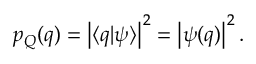Convert formula to latex. <formula><loc_0><loc_0><loc_500><loc_500>\begin{array} { r } { p _ { Q } ( q ) = \left | \langle q | \psi \rangle \right | ^ { 2 } = \left | \psi ( q ) \right | ^ { 2 } . } \end{array}</formula> 